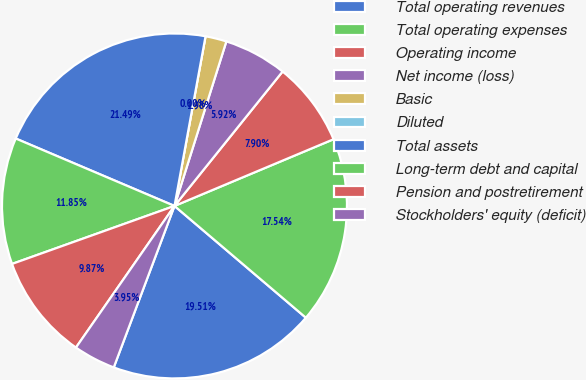<chart> <loc_0><loc_0><loc_500><loc_500><pie_chart><fcel>Total operating revenues<fcel>Total operating expenses<fcel>Operating income<fcel>Net income (loss)<fcel>Basic<fcel>Diluted<fcel>Total assets<fcel>Long-term debt and capital<fcel>Pension and postretirement<fcel>Stockholders' equity (deficit)<nl><fcel>19.51%<fcel>17.54%<fcel>7.9%<fcel>5.92%<fcel>1.98%<fcel>0.0%<fcel>21.49%<fcel>11.85%<fcel>9.87%<fcel>3.95%<nl></chart> 